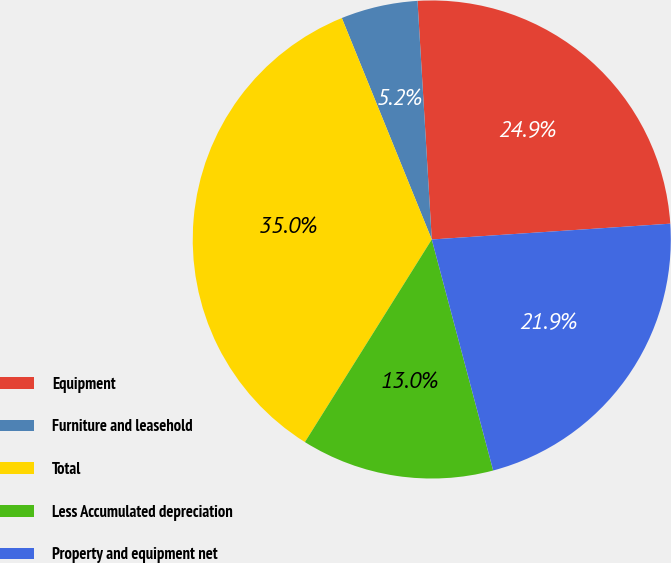<chart> <loc_0><loc_0><loc_500><loc_500><pie_chart><fcel>Equipment<fcel>Furniture and leasehold<fcel>Total<fcel>Less Accumulated depreciation<fcel>Property and equipment net<nl><fcel>24.9%<fcel>5.19%<fcel>34.96%<fcel>13.04%<fcel>21.92%<nl></chart> 